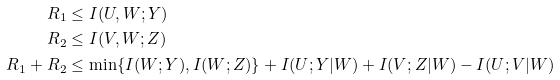<formula> <loc_0><loc_0><loc_500><loc_500>R _ { 1 } & \leq I ( U , W ; Y ) \\ R _ { 2 } & \leq I ( V , W ; Z ) \\ R _ { 1 } + R _ { 2 } & \leq \min \{ I ( W ; Y ) , I ( W ; Z ) \} + I ( U ; Y | W ) + I ( V ; Z | W ) - I ( U ; V | W )</formula> 